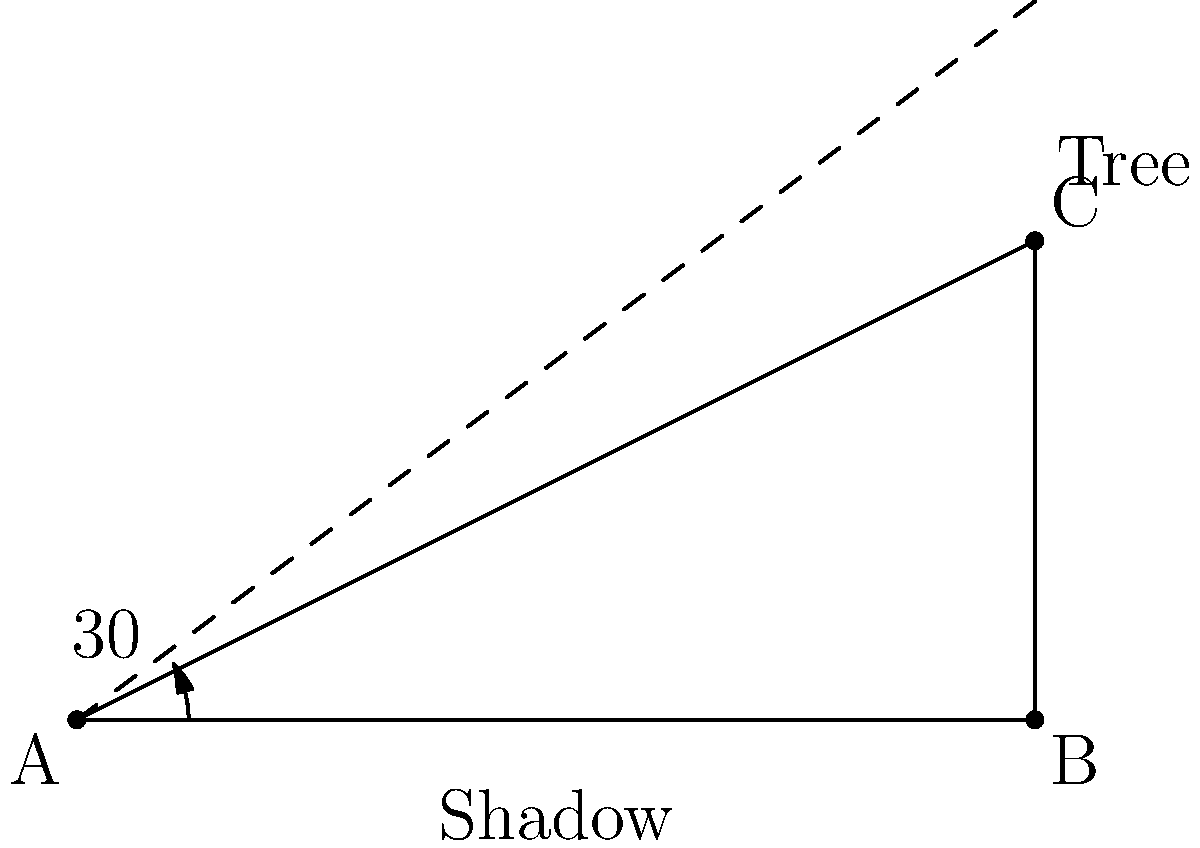At 4:00 PM, the sun's angle is 30° above the horizon. If a tree casts a shadow that is 6 meters long, how tall is the tree? Round your answer to the nearest centimeter. Let's approach this step-by-step:

1) We can use the tangent function to solve this problem. The tangent of an angle in a right triangle is the ratio of the opposite side to the adjacent side.

2) In this case:
   - The angle is 30°
   - The adjacent side (shadow length) is 6 meters
   - The opposite side (tree height) is what we're trying to find

3) Let's call the tree height $h$. We can write the equation:

   $\tan(30°) = \frac{h}{6}$

4) We know that $\tan(30°) = \frac{1}{\sqrt{3}} \approx 0.577$

5) Substituting this in:

   $0.577 = \frac{h}{6}$

6) Multiply both sides by 6:

   $6 * 0.577 = h$

7) Calculate:

   $h = 3.462$ meters

8) Rounding to the nearest centimeter:

   $h = 3.46$ meters or 346 cm

Therefore, the tree is approximately 3.46 meters or 346 cm tall.
Answer: 346 cm 